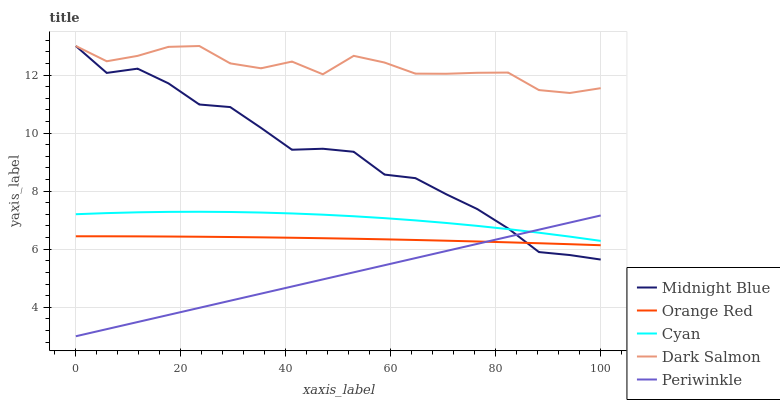Does Periwinkle have the minimum area under the curve?
Answer yes or no. Yes. Does Dark Salmon have the maximum area under the curve?
Answer yes or no. Yes. Does Dark Salmon have the minimum area under the curve?
Answer yes or no. No. Does Periwinkle have the maximum area under the curve?
Answer yes or no. No. Is Periwinkle the smoothest?
Answer yes or no. Yes. Is Dark Salmon the roughest?
Answer yes or no. Yes. Is Dark Salmon the smoothest?
Answer yes or no. No. Is Periwinkle the roughest?
Answer yes or no. No. Does Periwinkle have the lowest value?
Answer yes or no. Yes. Does Dark Salmon have the lowest value?
Answer yes or no. No. Does Midnight Blue have the highest value?
Answer yes or no. Yes. Does Periwinkle have the highest value?
Answer yes or no. No. Is Orange Red less than Dark Salmon?
Answer yes or no. Yes. Is Cyan greater than Orange Red?
Answer yes or no. Yes. Does Periwinkle intersect Orange Red?
Answer yes or no. Yes. Is Periwinkle less than Orange Red?
Answer yes or no. No. Is Periwinkle greater than Orange Red?
Answer yes or no. No. Does Orange Red intersect Dark Salmon?
Answer yes or no. No. 